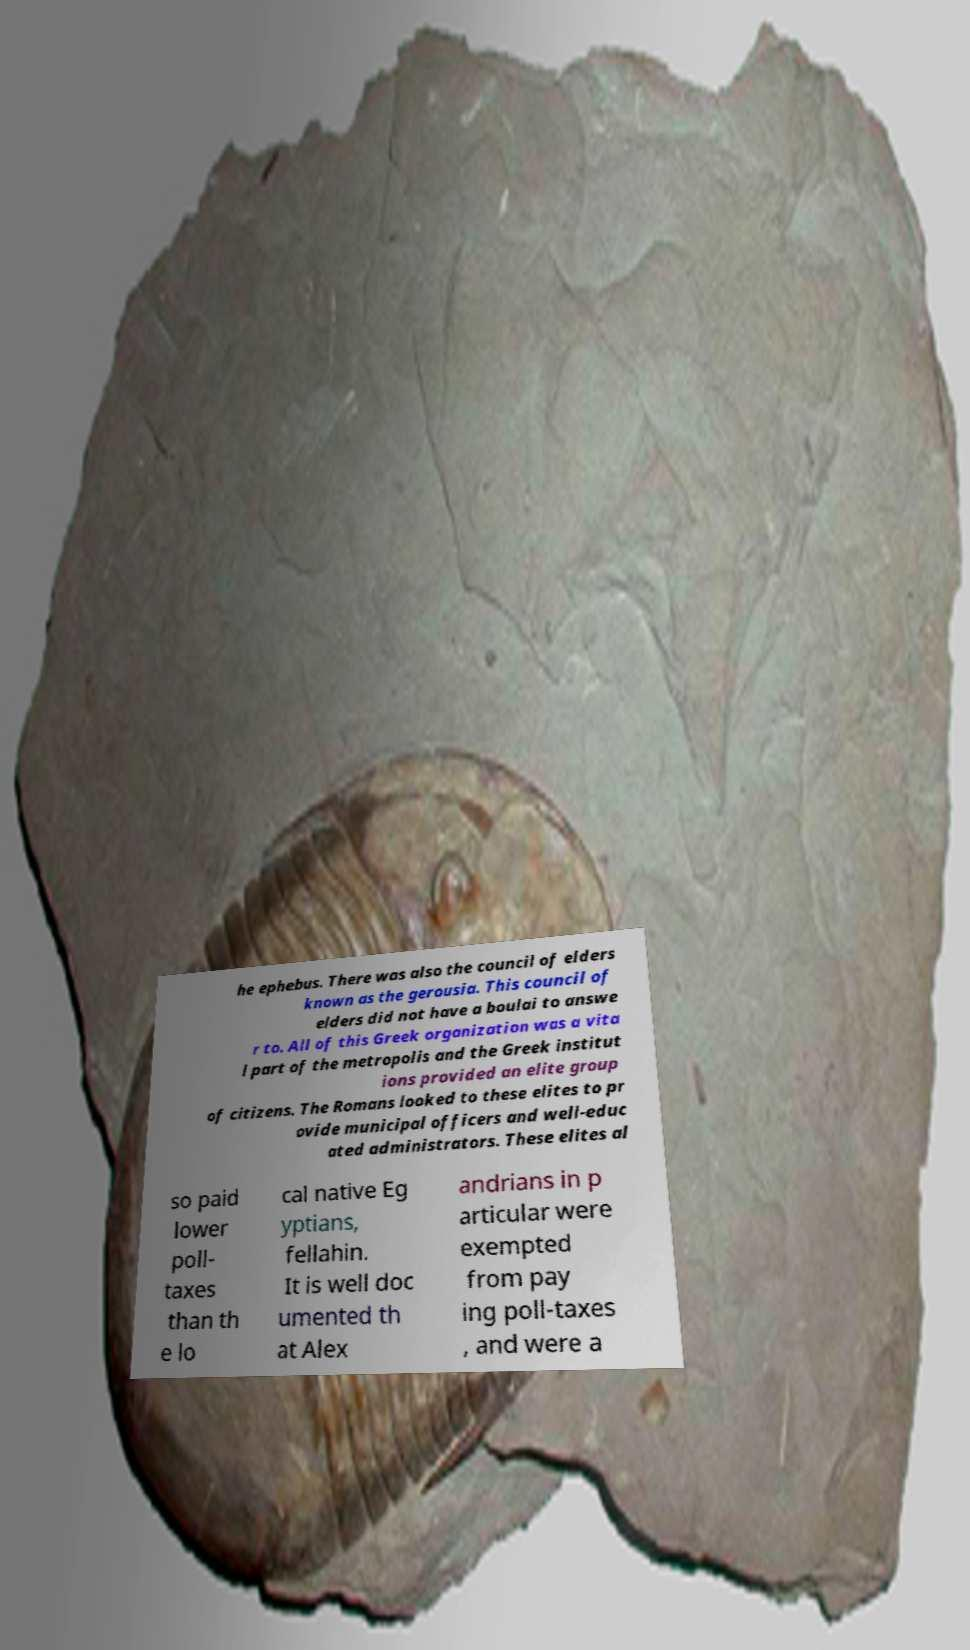Please identify and transcribe the text found in this image. he ephebus. There was also the council of elders known as the gerousia. This council of elders did not have a boulai to answe r to. All of this Greek organization was a vita l part of the metropolis and the Greek institut ions provided an elite group of citizens. The Romans looked to these elites to pr ovide municipal officers and well-educ ated administrators. These elites al so paid lower poll- taxes than th e lo cal native Eg yptians, fellahin. It is well doc umented th at Alex andrians in p articular were exempted from pay ing poll-taxes , and were a 